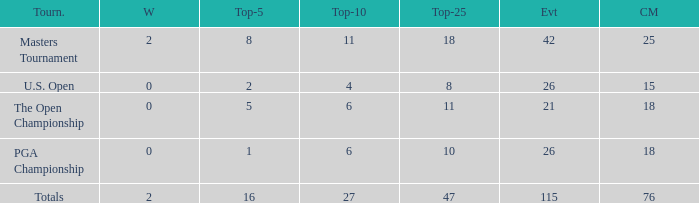What are the largest cuts made when the events are less than 21? None. 